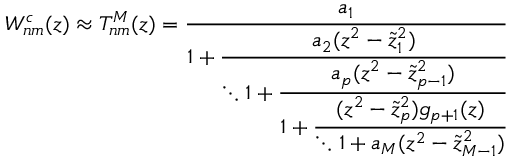Convert formula to latex. <formula><loc_0><loc_0><loc_500><loc_500>W _ { n m } ^ { c } ( z ) \approx T _ { n m } ^ { M } ( z ) = \cfrac { a _ { 1 } } { 1 + \cfrac { a _ { 2 } ( z ^ { 2 } - \tilde { z } _ { 1 } ^ { 2 } ) } { \ddots 1 + \cfrac { a _ { p } ( z ^ { 2 } - \tilde { z } _ { p - 1 } ^ { 2 } ) } { 1 + \cfrac { ( z ^ { 2 } - \tilde { z } _ { p } ^ { 2 } ) g _ { p + 1 } ( z ) } { \ddots 1 + a _ { M } ( z ^ { 2 } - \tilde { z } _ { M - 1 } ^ { 2 } ) } } } } \,</formula> 